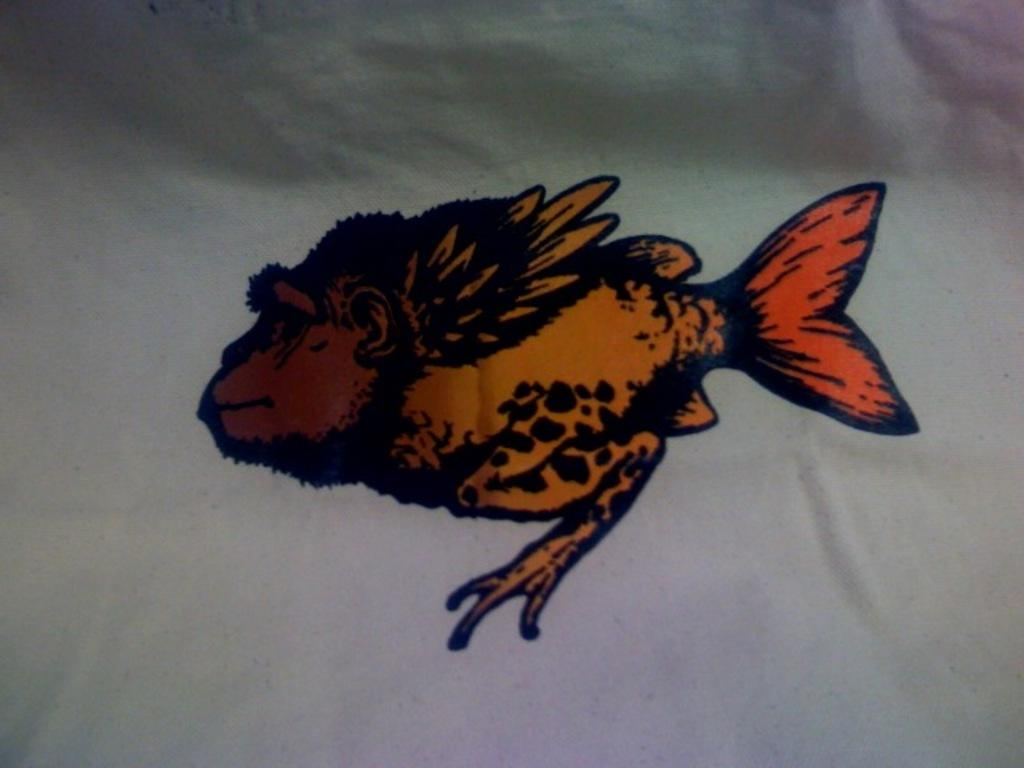What is depicted in the painting in the image? There is a painting of a fish in the image. What material is the painting on? The painting is on a cloth. What color is the background of the image? The background of the image is white. How many books are stacked next to the painting in the image? There is no mention of books in the image, so we cannot determine how many there are. 